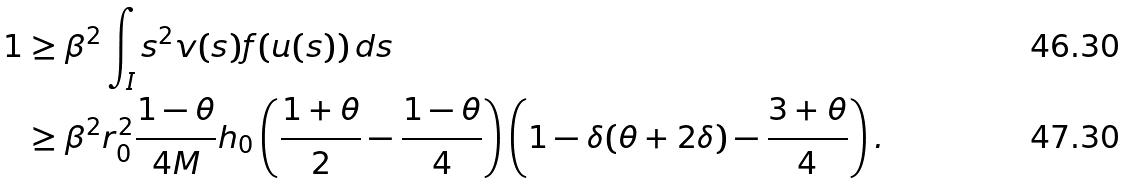<formula> <loc_0><loc_0><loc_500><loc_500>1 & \geq \beta ^ { 2 } \int _ { I } s ^ { 2 } v ( s ) f ( u ( s ) ) \, d s \\ & \geq \beta ^ { 2 } r _ { 0 } ^ { 2 } \frac { 1 - \theta } { 4 M } h _ { 0 } \left ( \frac { 1 + \theta } { 2 } - \frac { 1 - \theta } { 4 } \right ) \left ( 1 - \delta ( \theta + 2 \delta ) - \frac { 3 + \theta } { 4 } \right ) .</formula> 